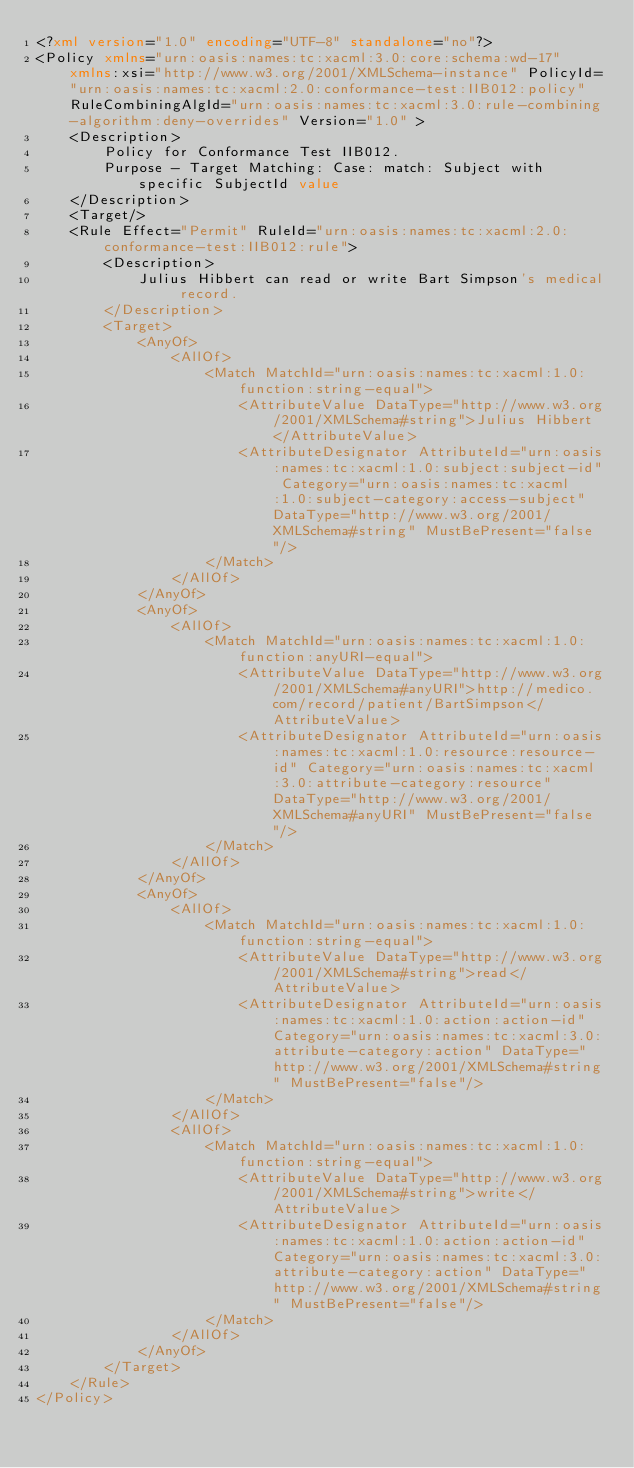Convert code to text. <code><loc_0><loc_0><loc_500><loc_500><_XML_><?xml version="1.0" encoding="UTF-8" standalone="no"?>
<Policy xmlns="urn:oasis:names:tc:xacml:3.0:core:schema:wd-17" xmlns:xsi="http://www.w3.org/2001/XMLSchema-instance" PolicyId="urn:oasis:names:tc:xacml:2.0:conformance-test:IIB012:policy" RuleCombiningAlgId="urn:oasis:names:tc:xacml:3.0:rule-combining-algorithm:deny-overrides" Version="1.0" >
    <Description>
        Policy for Conformance Test IIB012.
        Purpose - Target Matching: Case: match: Subject with specific SubjectId value
    </Description>
    <Target/>
    <Rule Effect="Permit" RuleId="urn:oasis:names:tc:xacml:2.0:conformance-test:IIB012:rule">
        <Description>
            Julius Hibbert can read or write Bart Simpson's medical record.
        </Description>
        <Target>
            <AnyOf>
                <AllOf>
                    <Match MatchId="urn:oasis:names:tc:xacml:1.0:function:string-equal">
                        <AttributeValue DataType="http://www.w3.org/2001/XMLSchema#string">Julius Hibbert</AttributeValue>
                        <AttributeDesignator AttributeId="urn:oasis:names:tc:xacml:1.0:subject:subject-id" Category="urn:oasis:names:tc:xacml:1.0:subject-category:access-subject" DataType="http://www.w3.org/2001/XMLSchema#string" MustBePresent="false"/>
                    </Match>
                </AllOf>
            </AnyOf>
            <AnyOf>
                <AllOf>
                    <Match MatchId="urn:oasis:names:tc:xacml:1.0:function:anyURI-equal">
                        <AttributeValue DataType="http://www.w3.org/2001/XMLSchema#anyURI">http://medico.com/record/patient/BartSimpson</AttributeValue>
                        <AttributeDesignator AttributeId="urn:oasis:names:tc:xacml:1.0:resource:resource-id" Category="urn:oasis:names:tc:xacml:3.0:attribute-category:resource" DataType="http://www.w3.org/2001/XMLSchema#anyURI" MustBePresent="false"/>
                    </Match>
                </AllOf>
            </AnyOf>
            <AnyOf>
                <AllOf>
                    <Match MatchId="urn:oasis:names:tc:xacml:1.0:function:string-equal">
                        <AttributeValue DataType="http://www.w3.org/2001/XMLSchema#string">read</AttributeValue>
                        <AttributeDesignator AttributeId="urn:oasis:names:tc:xacml:1.0:action:action-id" Category="urn:oasis:names:tc:xacml:3.0:attribute-category:action" DataType="http://www.w3.org/2001/XMLSchema#string" MustBePresent="false"/>
                    </Match>
                </AllOf>
                <AllOf>
                    <Match MatchId="urn:oasis:names:tc:xacml:1.0:function:string-equal">
                        <AttributeValue DataType="http://www.w3.org/2001/XMLSchema#string">write</AttributeValue>
                        <AttributeDesignator AttributeId="urn:oasis:names:tc:xacml:1.0:action:action-id" Category="urn:oasis:names:tc:xacml:3.0:attribute-category:action" DataType="http://www.w3.org/2001/XMLSchema#string" MustBePresent="false"/>
                    </Match>
                </AllOf>
            </AnyOf>
        </Target>
    </Rule>
</Policy>
</code> 